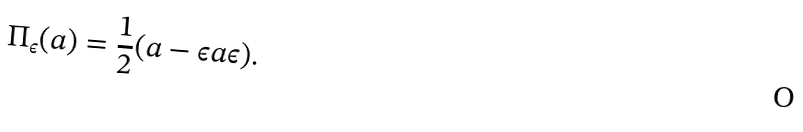<formula> <loc_0><loc_0><loc_500><loc_500>\Pi _ { \epsilon } ( a ) = \frac { 1 } { 2 } ( a - \epsilon a \epsilon ) .</formula> 